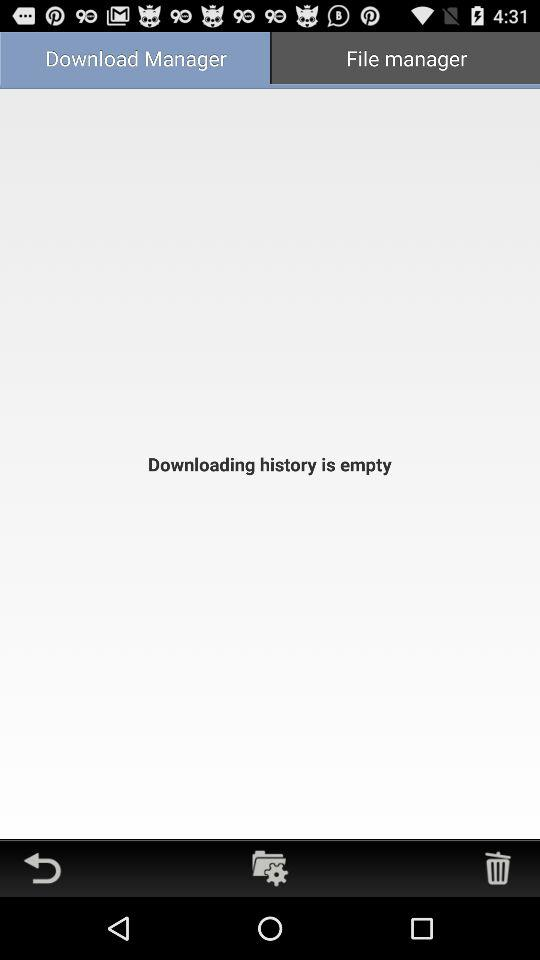Which tab is selected? The selected tab is "Download Manager". 